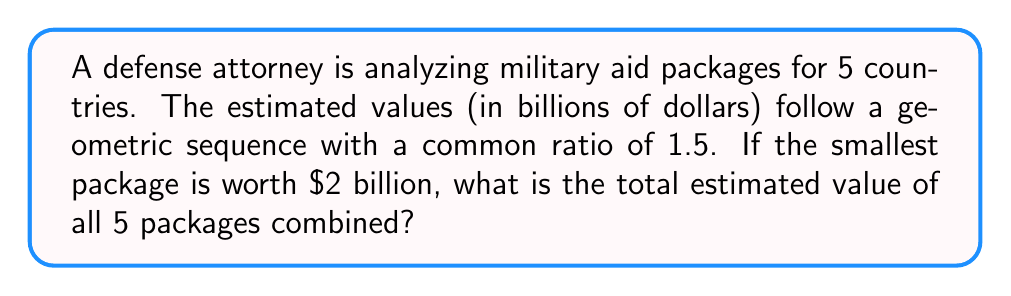Help me with this question. Let's approach this step-by-step:

1) We're dealing with a geometric sequence with 5 terms.
2) The first term, $a_1 = 2$ billion dollars.
3) The common ratio, $r = 1.5$.

4) In a geometric sequence, each term is found by multiplying the previous term by the common ratio. So the terms are:

   $a_1 = 2$
   $a_2 = 2 \cdot 1.5 = 3$
   $a_3 = 3 \cdot 1.5 = 4.5$
   $a_4 = 4.5 \cdot 1.5 = 6.75$
   $a_5 = 6.75 \cdot 1.5 = 10.125$

5) To find the sum of a geometric sequence, we can use the formula:

   $$S_n = \frac{a_1(1-r^n)}{1-r}$$

   Where $S_n$ is the sum of $n$ terms, $a_1$ is the first term, and $r$ is the common ratio.

6) Plugging in our values:

   $$S_5 = \frac{2(1-1.5^5)}{1-1.5}$$

7) Simplify:
   $$S_5 = \frac{2(1-7.59375)}{-0.5} = \frac{2(-6.59375)}{-0.5} = 26.375$$

Therefore, the total estimated value of all 5 packages is $26.375 billion.
Answer: $26.375 billion 